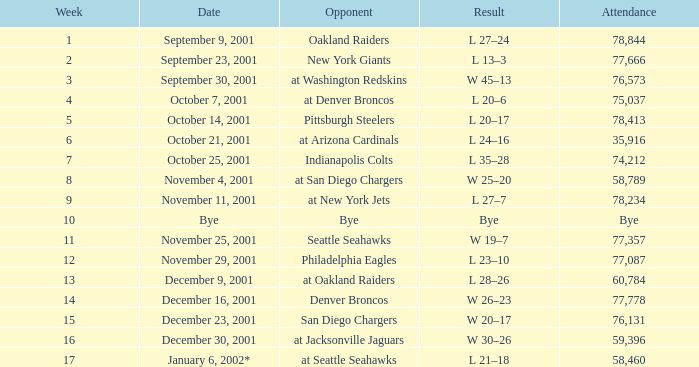What week is an off week? 10.0. 